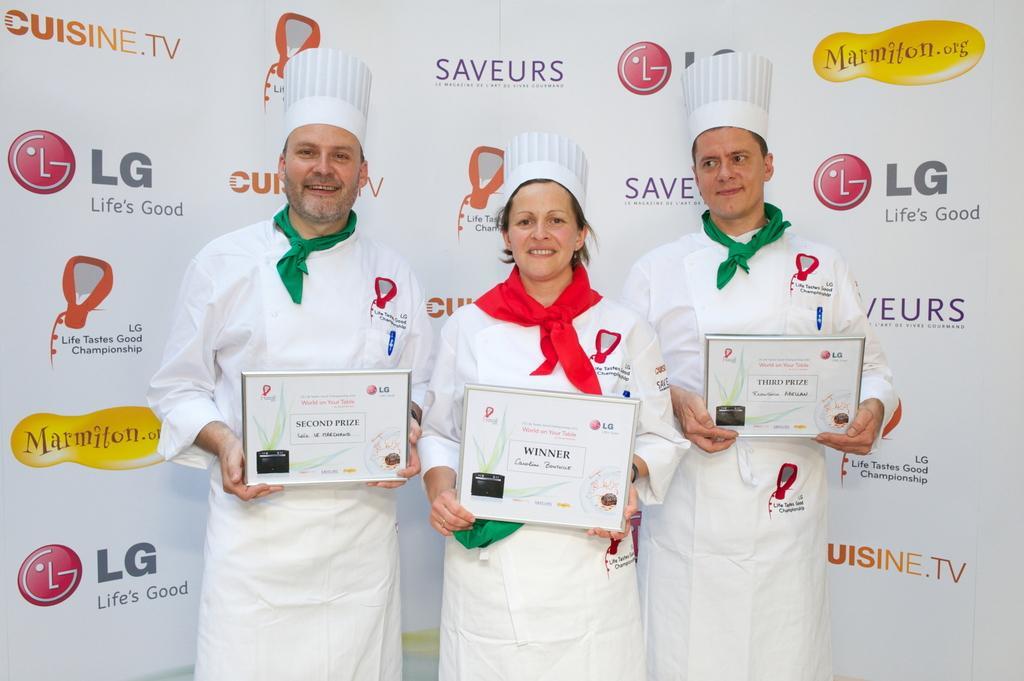Could you give a brief overview of what you see in this image? In this image, we can see a few people holding objects. In the background, we can see a poster with some images and text. 